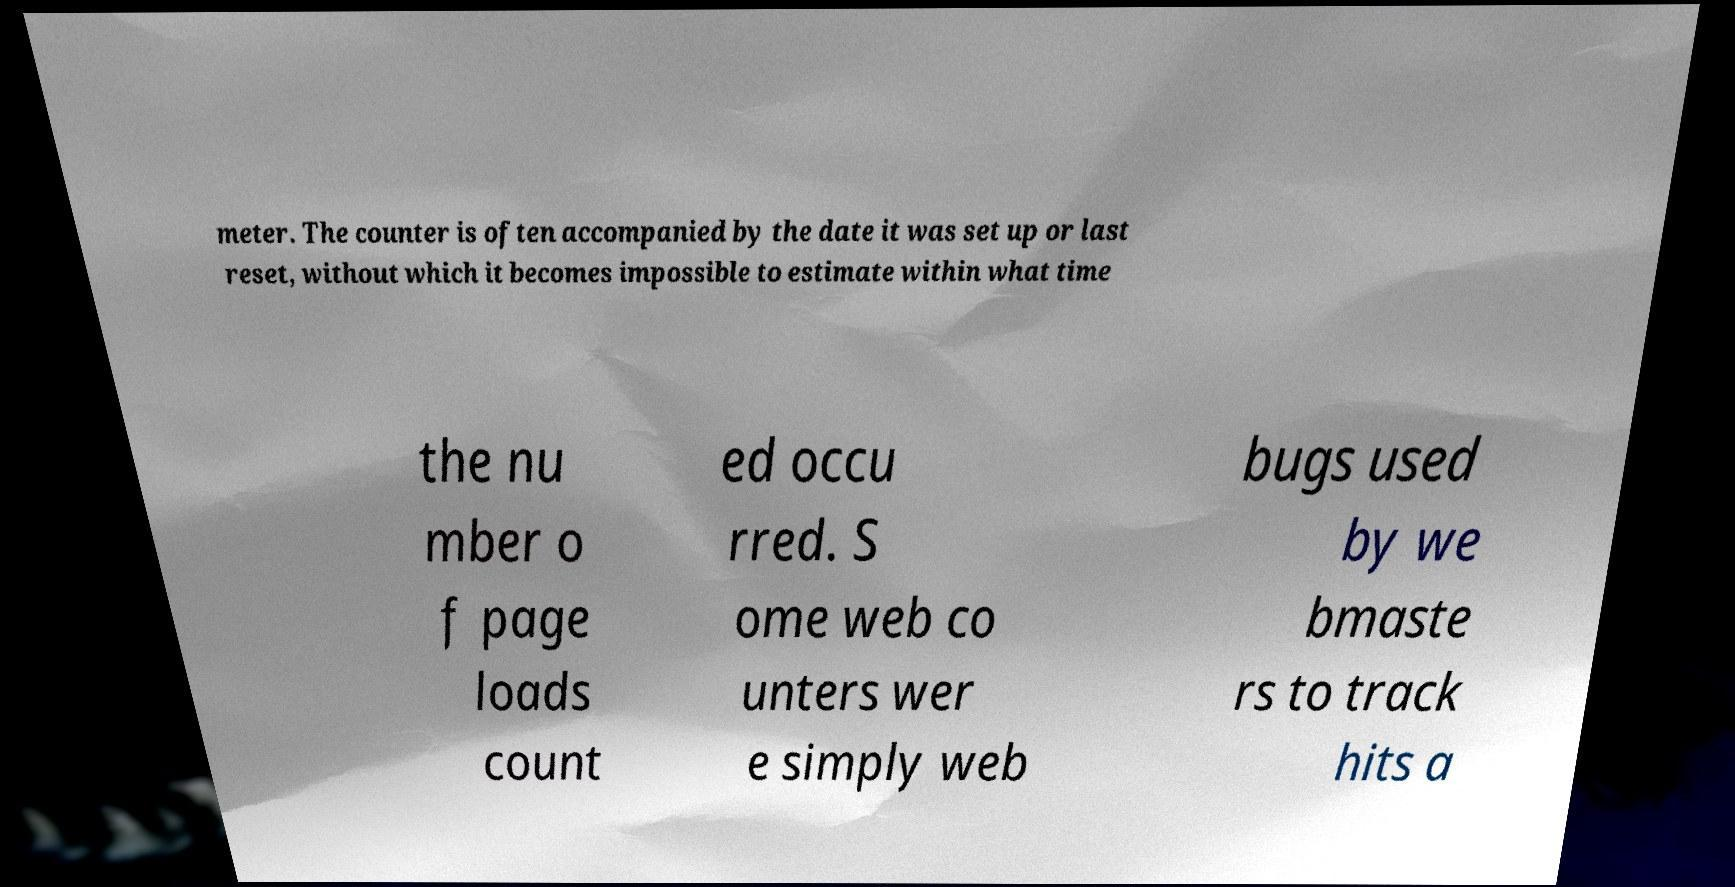Could you assist in decoding the text presented in this image and type it out clearly? meter. The counter is often accompanied by the date it was set up or last reset, without which it becomes impossible to estimate within what time the nu mber o f page loads count ed occu rred. S ome web co unters wer e simply web bugs used by we bmaste rs to track hits a 